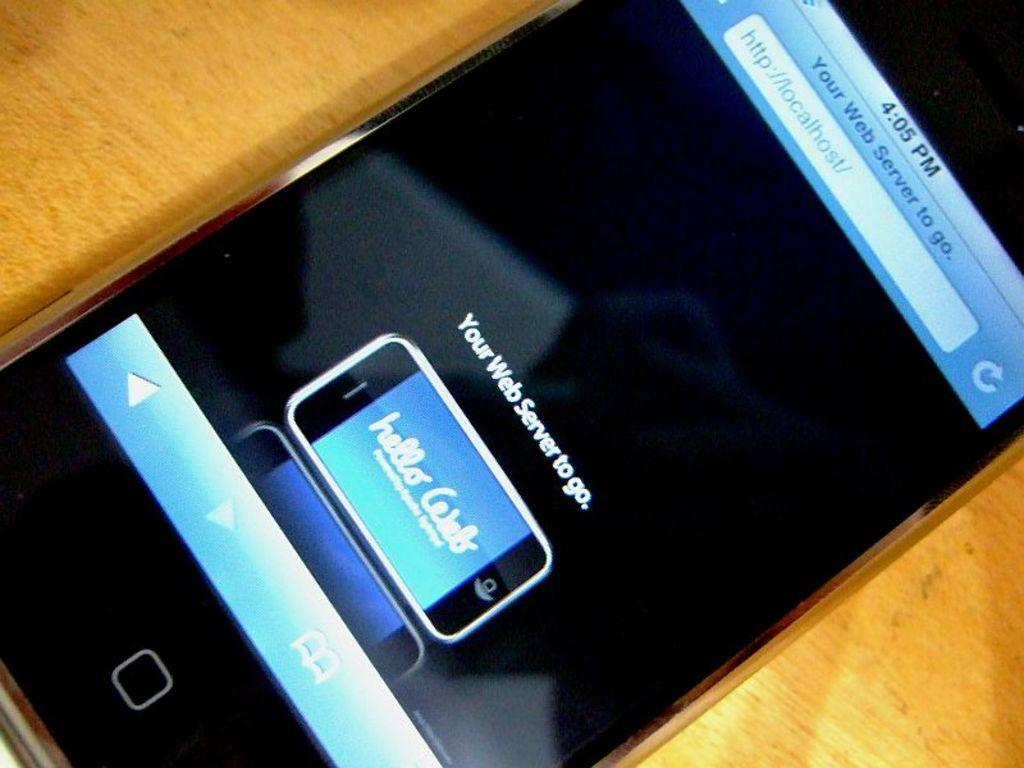What object is present in the image that is commonly used for communication? There is a phone in the image. On what type of surface is the phone placed? The phone is on a wooden surface. What type of finger can be seen using the phone in the image? There are no fingers visible in the image, as it only shows a phone on a wooden surface. What type of tool is used to cut materials, such as paper or fabric, in the image? There is no tool for cutting materials present in the image. What type of currency is visible in the image? There is no currency or money visible in the image. 